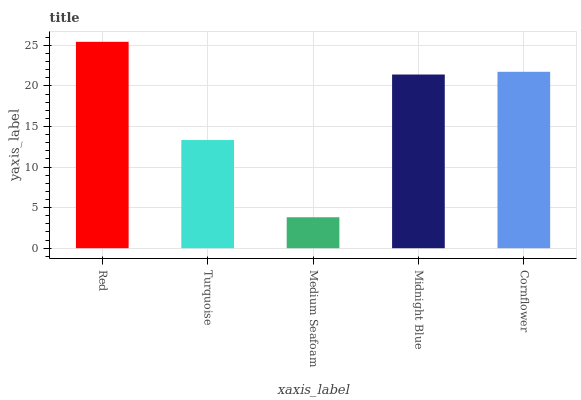Is Medium Seafoam the minimum?
Answer yes or no. Yes. Is Red the maximum?
Answer yes or no. Yes. Is Turquoise the minimum?
Answer yes or no. No. Is Turquoise the maximum?
Answer yes or no. No. Is Red greater than Turquoise?
Answer yes or no. Yes. Is Turquoise less than Red?
Answer yes or no. Yes. Is Turquoise greater than Red?
Answer yes or no. No. Is Red less than Turquoise?
Answer yes or no. No. Is Midnight Blue the high median?
Answer yes or no. Yes. Is Midnight Blue the low median?
Answer yes or no. Yes. Is Cornflower the high median?
Answer yes or no. No. Is Turquoise the low median?
Answer yes or no. No. 